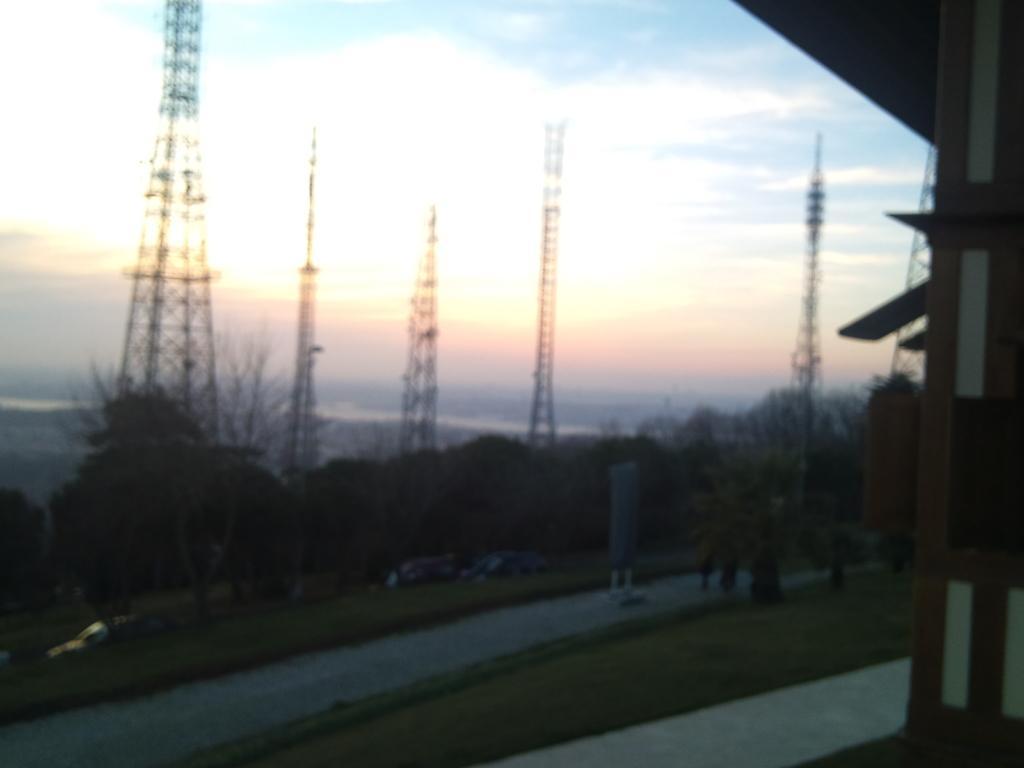Please provide a concise description of this image. In this picture we can see trees, towers, path and some objects and in the background we can see the sky. 